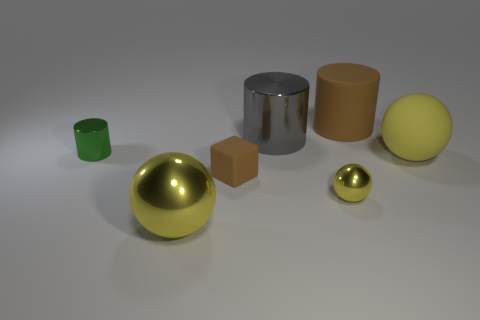What number of things are either brown rubber spheres or big brown things?
Your answer should be very brief. 1. There is a cylinder that is both behind the tiny green cylinder and left of the big brown matte cylinder; what material is it?
Offer a very short reply. Metal. Does the gray metallic object have the same size as the green object?
Provide a succinct answer. No. There is a shiny cylinder behind the tiny shiny thing that is behind the small brown rubber object; what size is it?
Provide a short and direct response. Large. How many big objects are behind the small cylinder and left of the gray shiny cylinder?
Your answer should be compact. 0. There is a brown thing in front of the large yellow ball that is behind the tiny brown block; are there any rubber things to the left of it?
Keep it short and to the point. No. There is a yellow rubber object that is the same size as the gray object; what is its shape?
Offer a terse response. Sphere. Are there any other rubber blocks that have the same color as the small rubber block?
Provide a succinct answer. No. Is the shape of the big brown matte object the same as the small green metallic thing?
Your response must be concise. Yes. How many big objects are either blue cubes or brown matte blocks?
Provide a succinct answer. 0. 